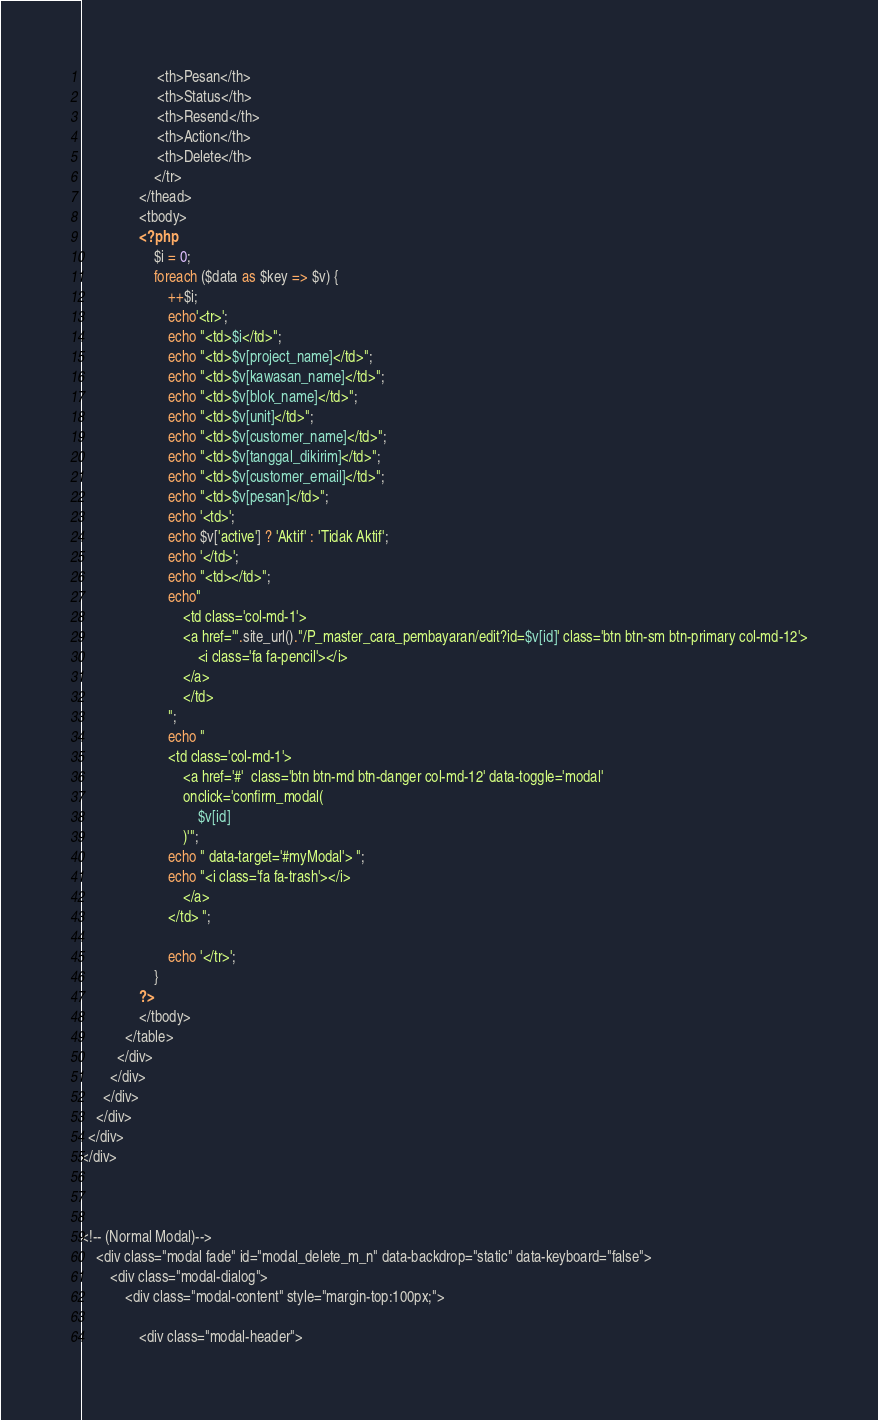<code> <loc_0><loc_0><loc_500><loc_500><_PHP_>                     <th>Pesan</th>
                     <th>Status</th>
                     <th>Resend</th>
                     <th>Action</th>
                     <th>Delete</th>
                    </tr>
                </thead>
                <tbody>
                <?php
                    $i = 0;
                    foreach ($data as $key => $v) {
                        ++$i;
                        echo'<tr>';
                        echo "<td>$i</td>";
                        echo "<td>$v[project_name]</td>";
                        echo "<td>$v[kawasan_name]</td>";
                        echo "<td>$v[blok_name]</td>";
                        echo "<td>$v[unit]</td>";
                        echo "<td>$v[customer_name]</td>";
                        echo "<td>$v[tanggal_dikirim]</td>";
                        echo "<td>$v[customer_email]</td>";
                        echo "<td>$v[pesan]</td>";
                        echo '<td>';
                        echo $v['active'] ? 'Aktif' : 'Tidak Aktif';
                        echo '</td>';
                        echo "<td></td>";
                        echo"
                            <td class='col-md-1'>
                            <a href='".site_url()."/P_master_cara_pembayaran/edit?id=$v[id]' class='btn btn-sm btn-primary col-md-12'>
                                <i class='fa fa-pencil'></i>
                            </a>
                            </td>
                        ";
                        echo "
                        <td class='col-md-1'>
							<a href='#'  class='btn btn-md btn-danger col-md-12' data-toggle='modal' 
							onclick='confirm_modal(
								$v[id]
							)'";
                        echo " data-target='#myModal'> ";
                        echo "<i class='fa fa-trash'></i>
							</a>
						</td> ";

                        echo '</tr>';
                    }
                ?>
                </tbody>
            </table>
          </div>
        </div>
      </div>
    </div>
  </div>
</div>



<!-- (Normal Modal)-->
	<div class="modal fade" id="modal_delete_m_n" data-backdrop="static" data-keyboard="false">
		<div class="modal-dialog">
			<div class="modal-content" style="margin-top:100px;">

				<div class="modal-header"></code> 